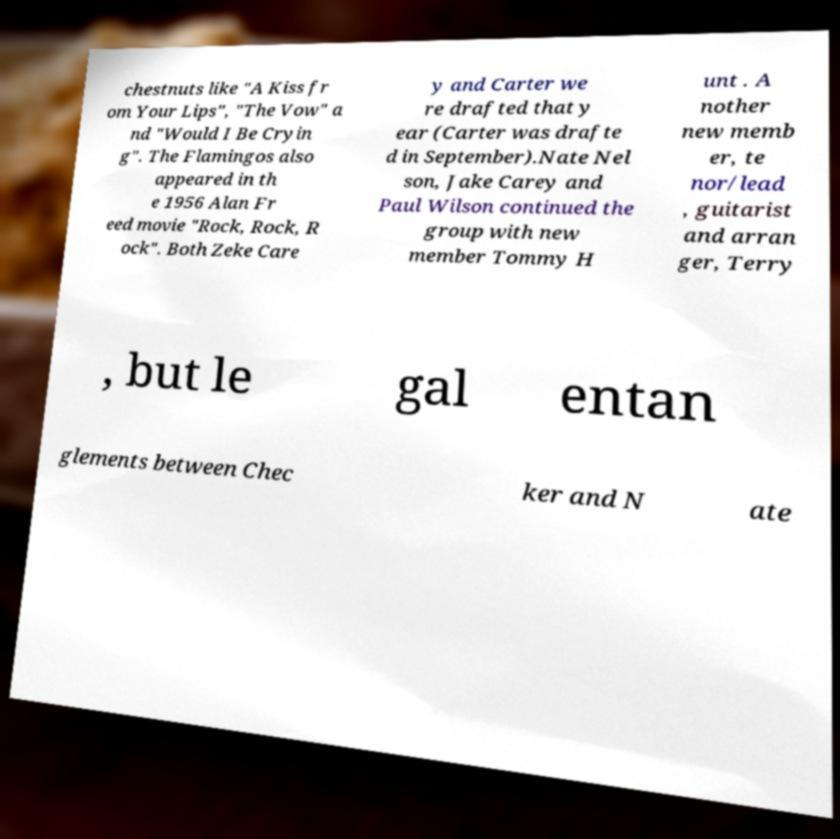Could you extract and type out the text from this image? chestnuts like "A Kiss fr om Your Lips", "The Vow" a nd "Would I Be Cryin g". The Flamingos also appeared in th e 1956 Alan Fr eed movie "Rock, Rock, R ock". Both Zeke Care y and Carter we re drafted that y ear (Carter was drafte d in September).Nate Nel son, Jake Carey and Paul Wilson continued the group with new member Tommy H unt . A nother new memb er, te nor/lead , guitarist and arran ger, Terry , but le gal entan glements between Chec ker and N ate 